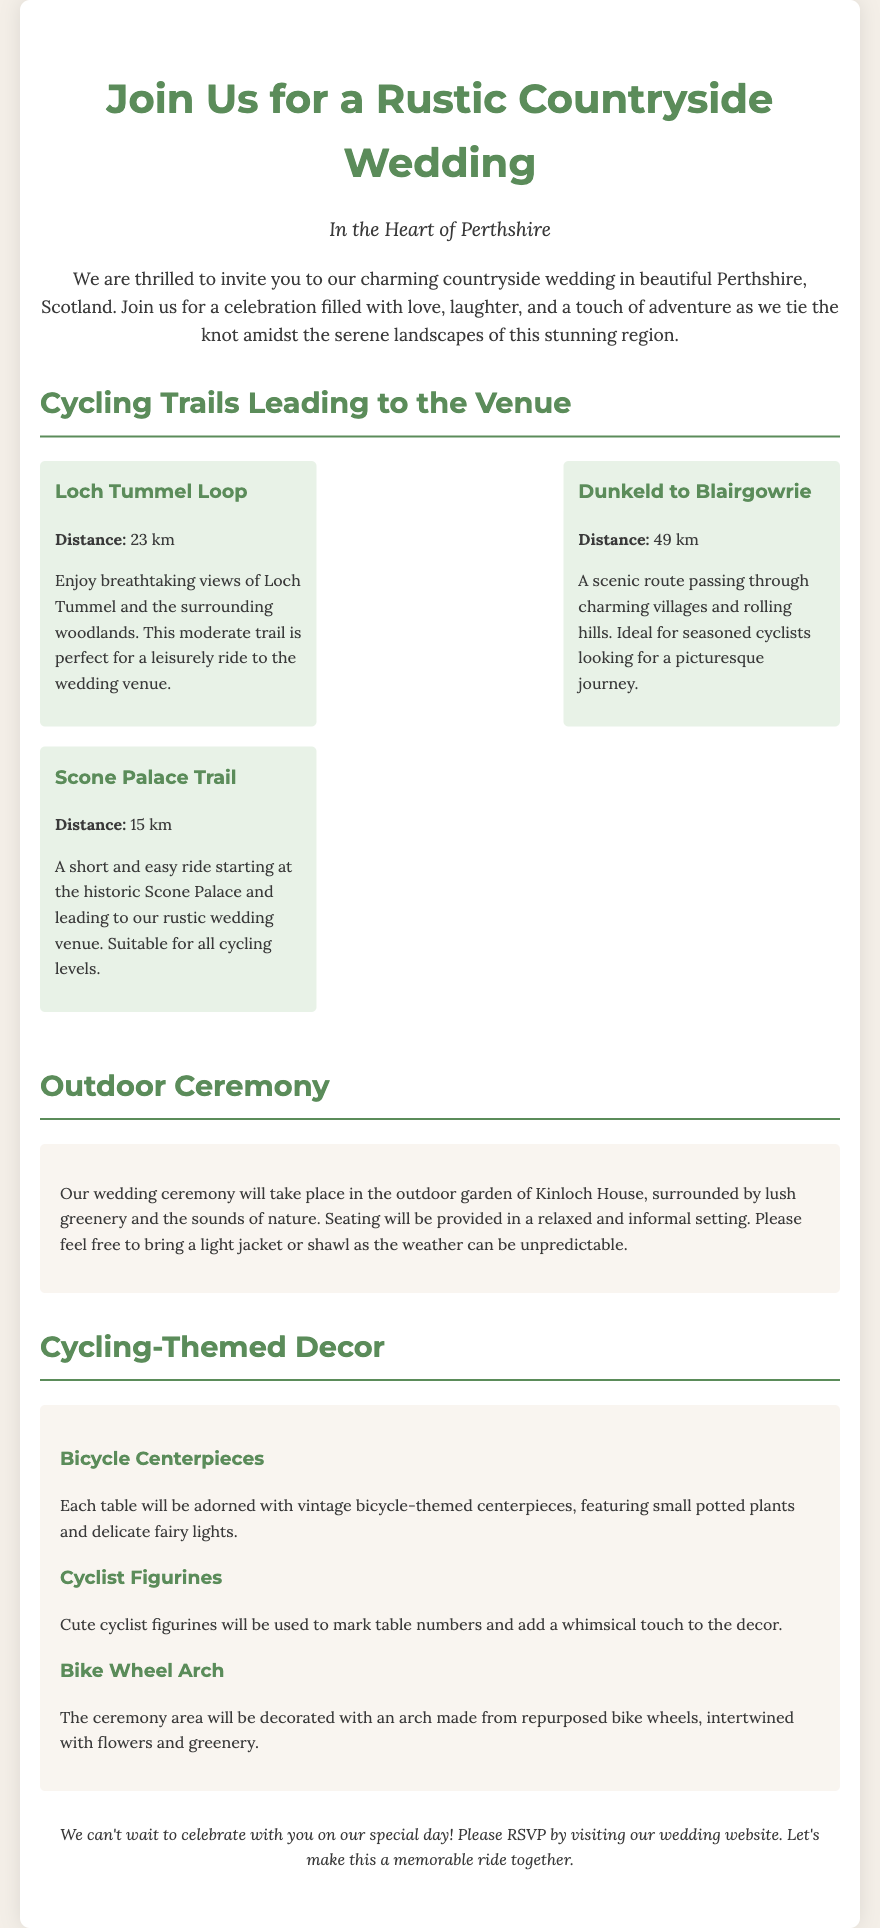what is the location of the wedding? The invitation mentions that the wedding is in the Heart of Perthshire, Scotland.
Answer: Heart of Perthshire what is the distance of the Loch Tummel Loop trail? The document states that the Loch Tummel Loop has a distance of 23 km.
Answer: 23 km how many cycling trails are listed in the invitation? The invitation lists three different cycling trails leading to the venue.
Answer: 3 what type of decor will be used at the wedding tables? The document mentions vintage bicycle-themed centerpieces for the tables.
Answer: Bicycle Centerpieces what type of setting will the outdoor ceremony have? The ceremony will take place in an outdoor garden surrounded by lush greenery.
Answer: Outdoor garden which figurines will be used to mark table numbers? The document mentions that cute cyclist figurines will be used for marking table numbers.
Answer: Cyclist Figurines is there a recommendation regarding clothing for the ceremony? The document suggests bringing a light jacket or shawl due to unpredictable weather.
Answer: Light jacket or shawl what is the closing statement in the invitation? The document concludes with a statement inviting guests to make the event a memorable ride together and to RSVP.
Answer: Make this a memorable ride together 